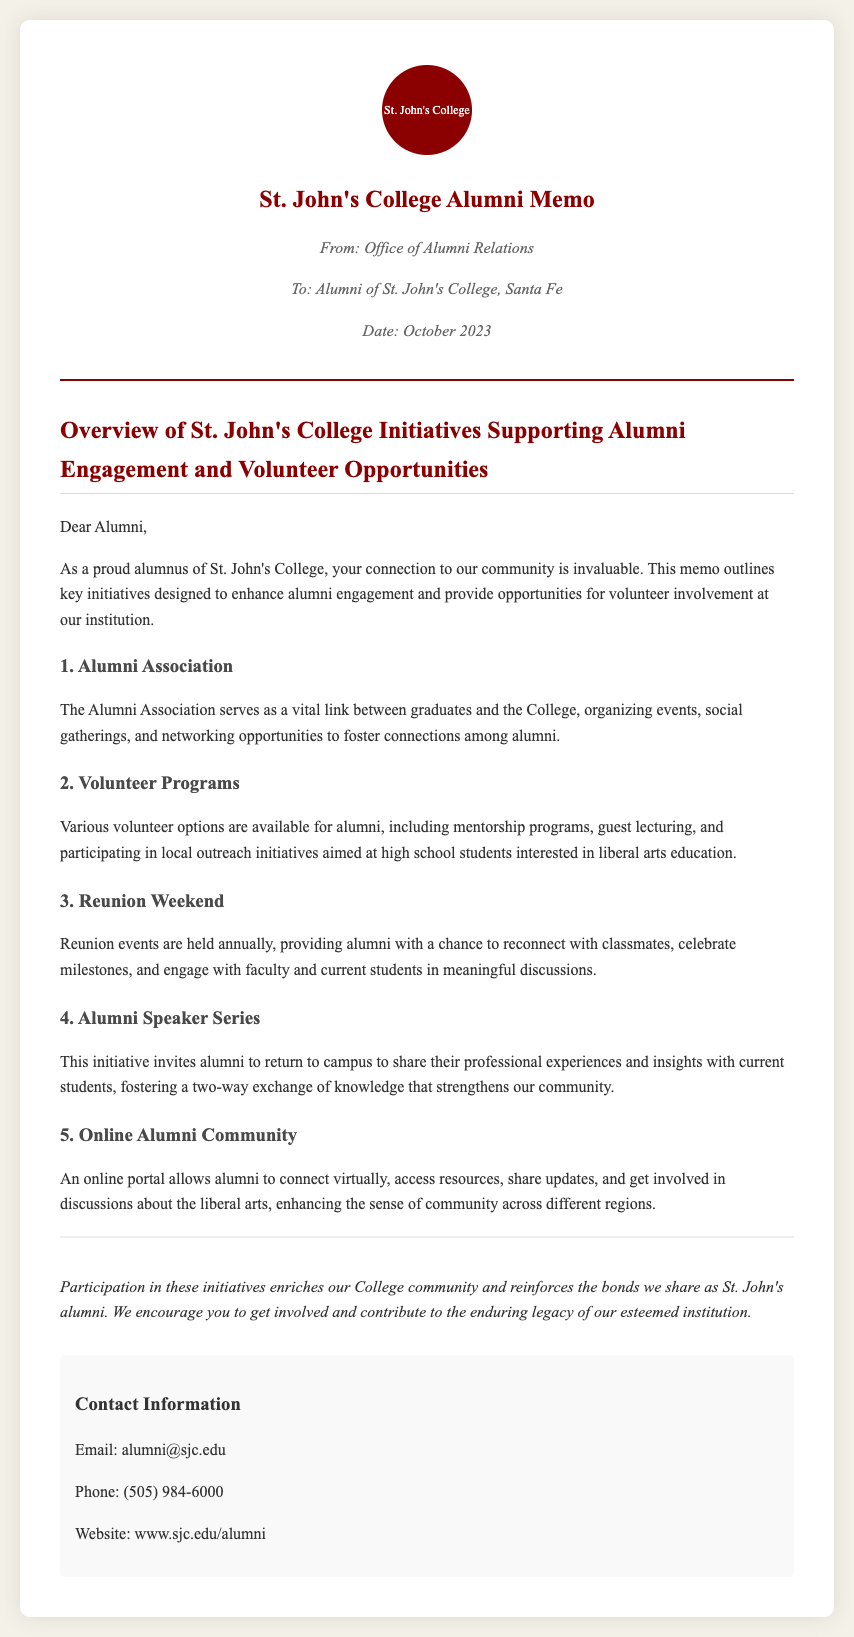What is the date of the memo? The date of the memo is clearly specified in the meta section of the document.
Answer: October 2023 How many key initiatives are mentioned? The document lists five specific initiatives geared towards alumni engagement and volunteer opportunities.
Answer: 5 What is the first initiative listed? The first initiative is in the numbered list, detailing its purpose and activities related to alumni engagement.
Answer: Alumni Association What is the purpose of the Volunteer Programs initiative? The Volunteer Programs initiative offers alumni various ways to get involved, including specific activities to support students interested in liberal arts.
Answer: Mentorship programs What contact method is provided for alumni? The document includes a section for contact information, offering direct ways for alumni to reach out to the Office of Alumni Relations.
Answer: Email: alumni@sjc.edu What is the focus of the Alumni Speaker Series? This initiative specifically targets the involvement of alumni through sharing experiences while fostering connection with current students.
Answer: Sharing professional experiences Why should alumni participate in these initiatives? The document emphasizes the importance of participation in building a strong community and upholding the legacy of St. John's College.
Answer: Enriches the College community What kind of community does the Online Alumni Community aim to enhance? The Online Alumni Community is designed to connect alumni across different regions while providing an interactive platform for resources and updates.
Answer: Sense of community What type of events do Reunion Weekends facilitate? The events mentioned encourage alumni to reconnect and engage meaningfully with classmates and faculty.
Answer: Reconnect with classmates 